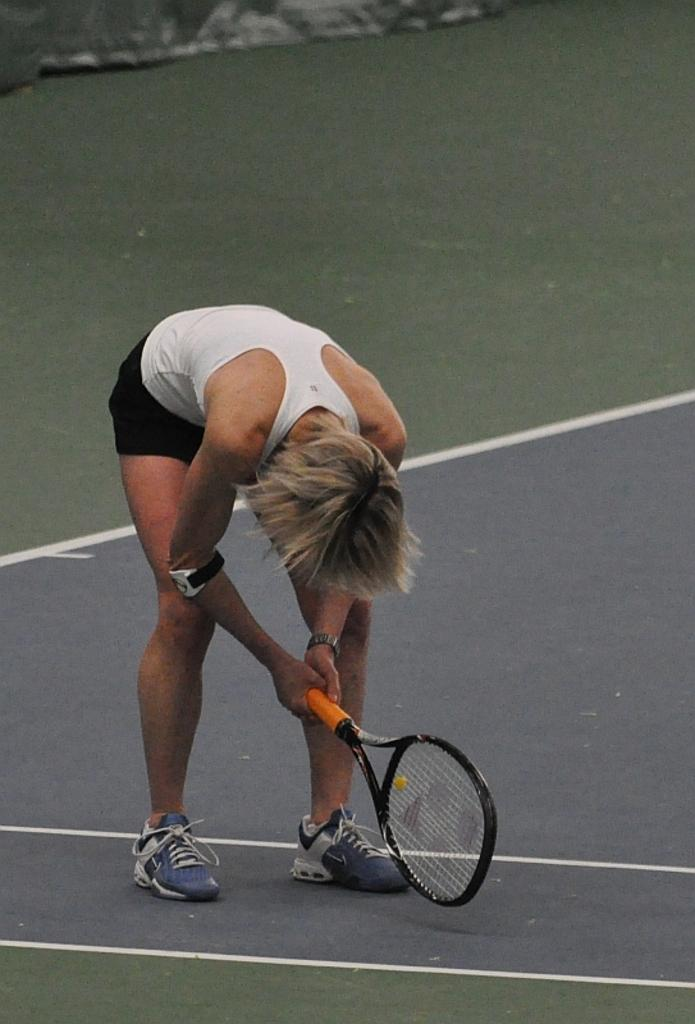What is the main subject of the image? There is a person in the image. What is the person doing in the image? The person is in a bending position and holding a tennis racket. What is the position of the tennis racket in the image? The tennis racket is on the ground. What else can be seen on the ground in the image? There is an object on the ground at the top of the image. What historical event is depicted in the image? There is no historical event depicted in the image; it shows a person holding a tennis racket in a bending position. Can you point out the map in the image? There is no map present in the image. 